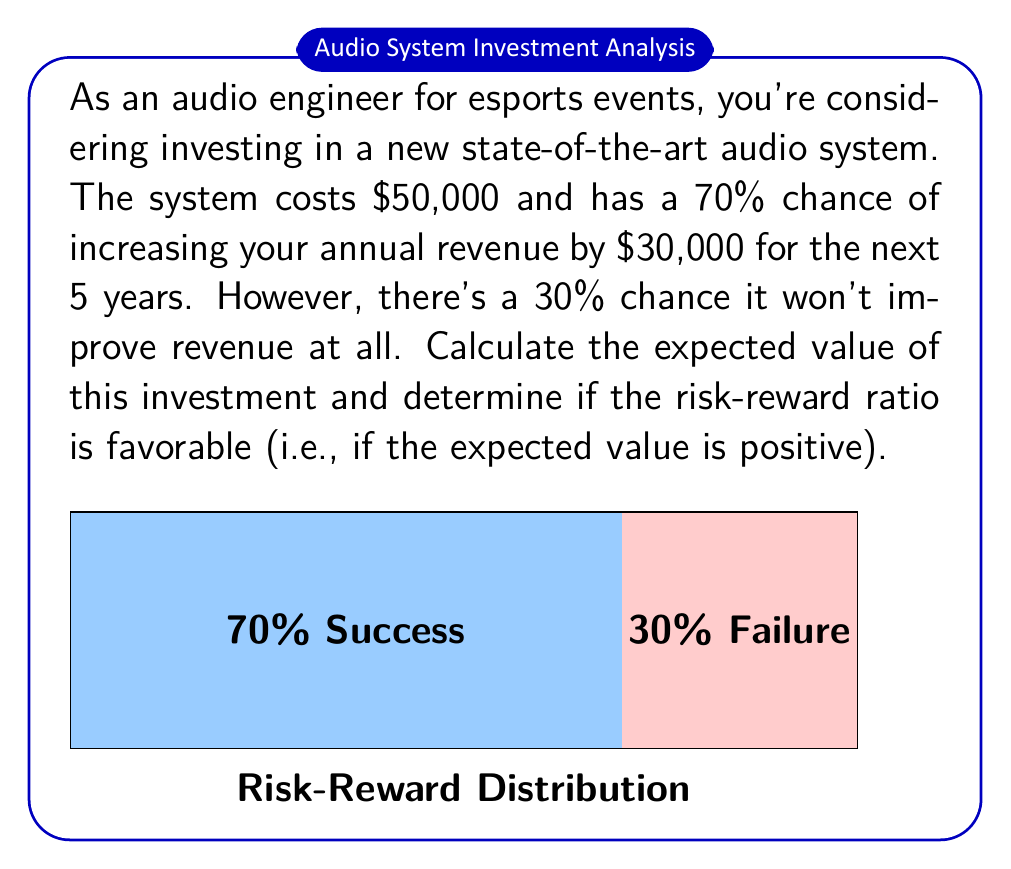Solve this math problem. Let's approach this problem step-by-step:

1) First, we need to calculate the potential revenue increase over 5 years:
   $$\text{Potential Revenue Increase} = \$30,000 \times 5 \text{ years} = \$150,000$$

2) Now, we can calculate the expected value of the revenue increase:
   $$E(\text{Revenue}) = 0.70 \times \$150,000 + 0.30 \times \$0 = \$105,000$$

3) The cost of the investment is $50,000. To find the expected value of the investment, we subtract this cost:
   $$E(\text{Investment}) = E(\text{Revenue}) - \text{Cost}$$
   $$E(\text{Investment}) = \$105,000 - \$50,000 = \$55,000$$

4) To determine if the risk-reward ratio is favorable, we check if the expected value is positive:
   $$\$55,000 > 0$$

5) We can also calculate the risk-reward ratio:
   $$\text{Risk-Reward Ratio} = \frac{\text{Potential Loss}}{\text{Potential Gain}} = \frac{\$50,000}{\$150,000} = \frac{1}{3}$$

   This means for every $1 of potential loss, there's $3 of potential gain.
Answer: $55,000; favorable 